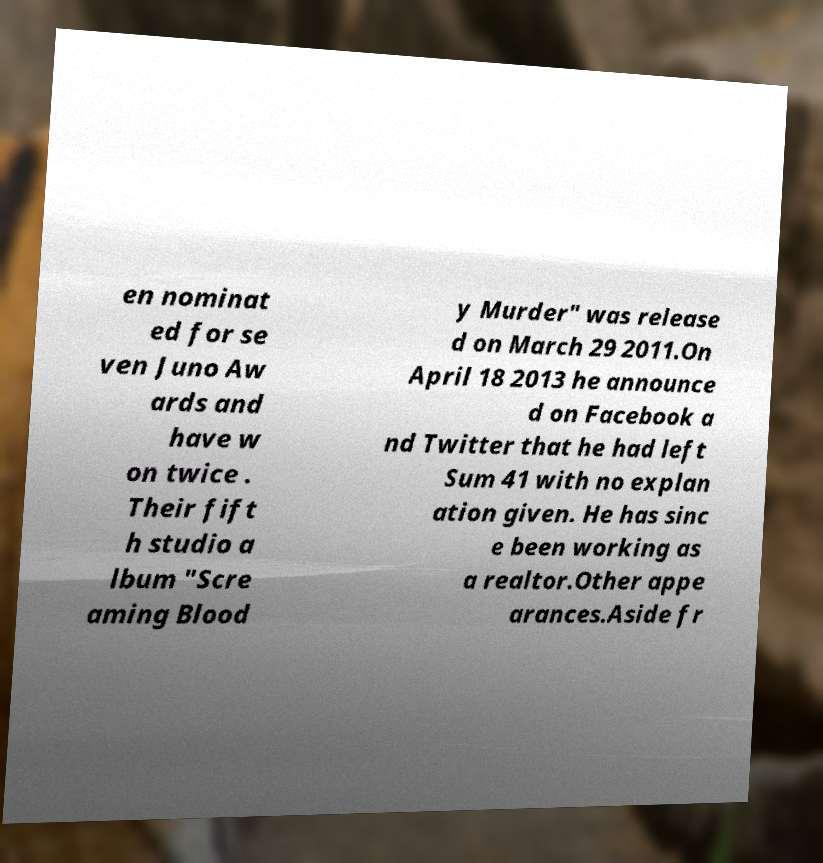Please identify and transcribe the text found in this image. en nominat ed for se ven Juno Aw ards and have w on twice . Their fift h studio a lbum "Scre aming Blood y Murder" was release d on March 29 2011.On April 18 2013 he announce d on Facebook a nd Twitter that he had left Sum 41 with no explan ation given. He has sinc e been working as a realtor.Other appe arances.Aside fr 